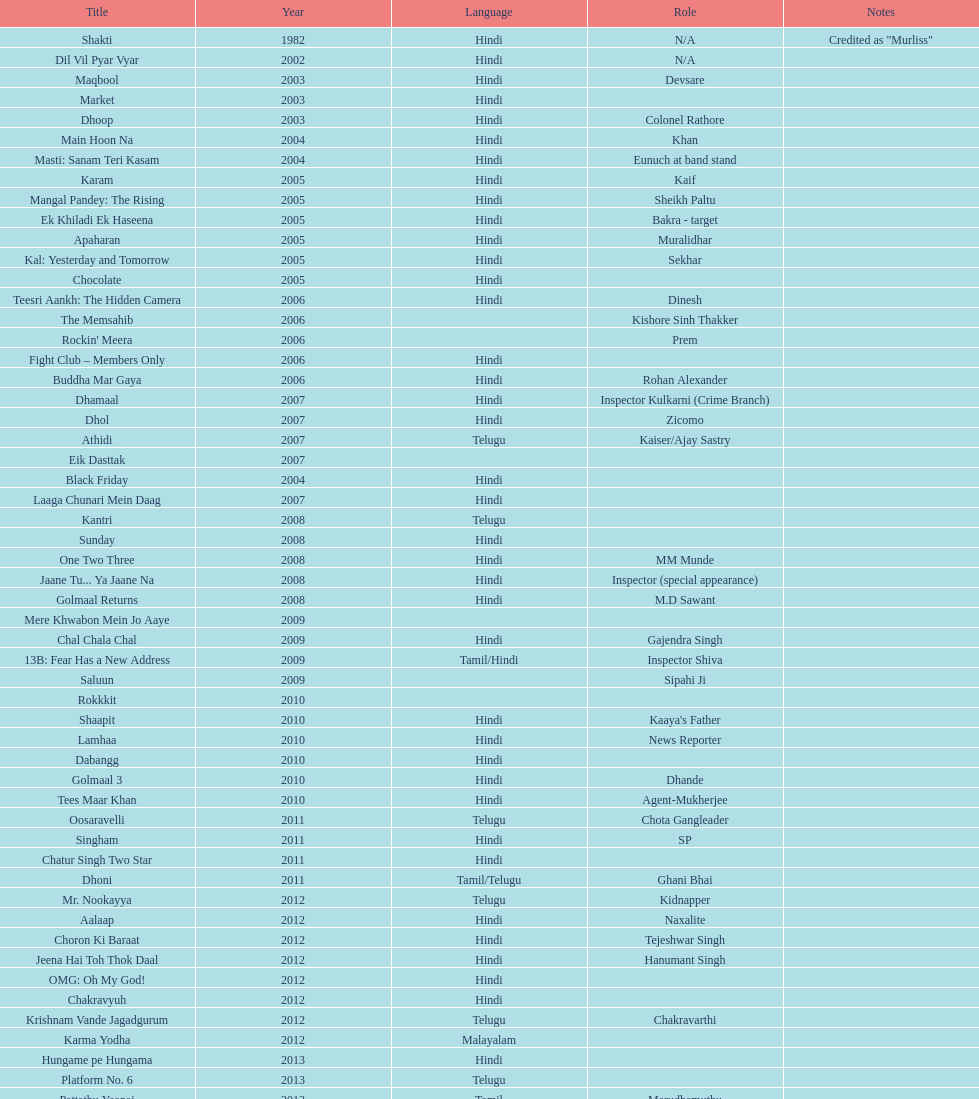How many parts has this actor played? 36. 